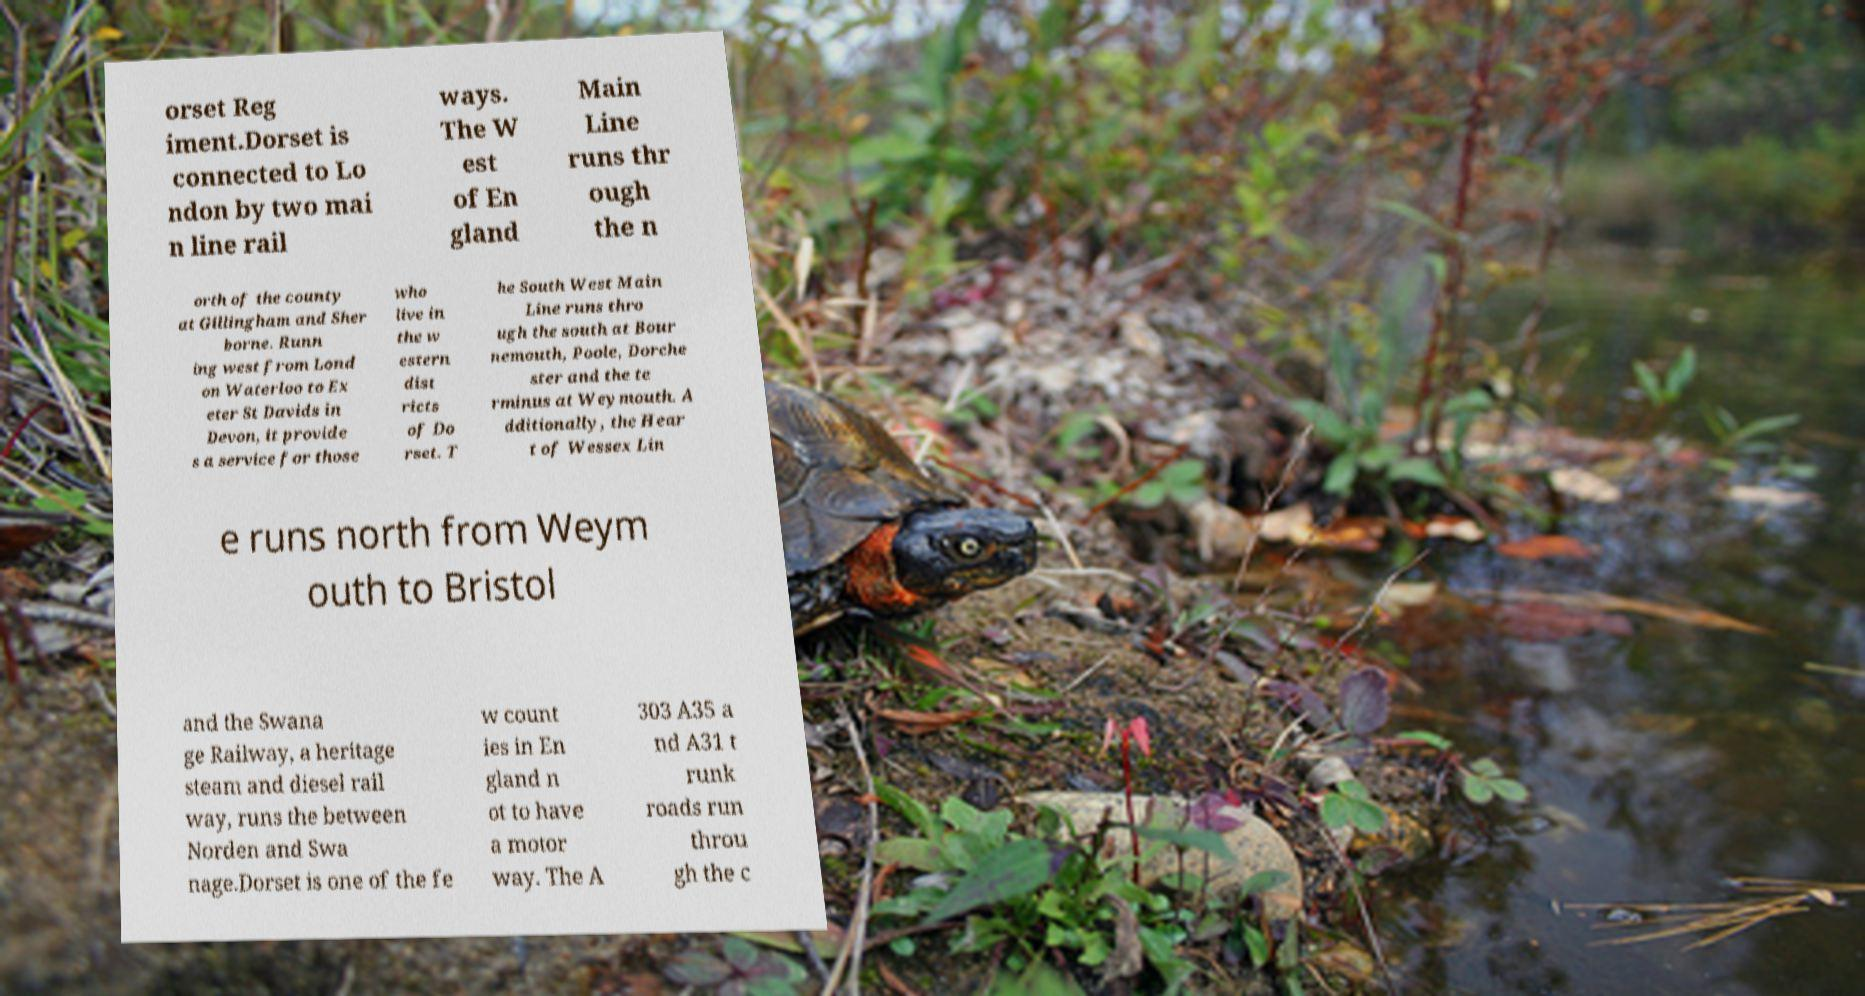Please identify and transcribe the text found in this image. orset Reg iment.Dorset is connected to Lo ndon by two mai n line rail ways. The W est of En gland Main Line runs thr ough the n orth of the county at Gillingham and Sher borne. Runn ing west from Lond on Waterloo to Ex eter St Davids in Devon, it provide s a service for those who live in the w estern dist ricts of Do rset. T he South West Main Line runs thro ugh the south at Bour nemouth, Poole, Dorche ster and the te rminus at Weymouth. A dditionally, the Hear t of Wessex Lin e runs north from Weym outh to Bristol and the Swana ge Railway, a heritage steam and diesel rail way, runs the between Norden and Swa nage.Dorset is one of the fe w count ies in En gland n ot to have a motor way. The A 303 A35 a nd A31 t runk roads run throu gh the c 